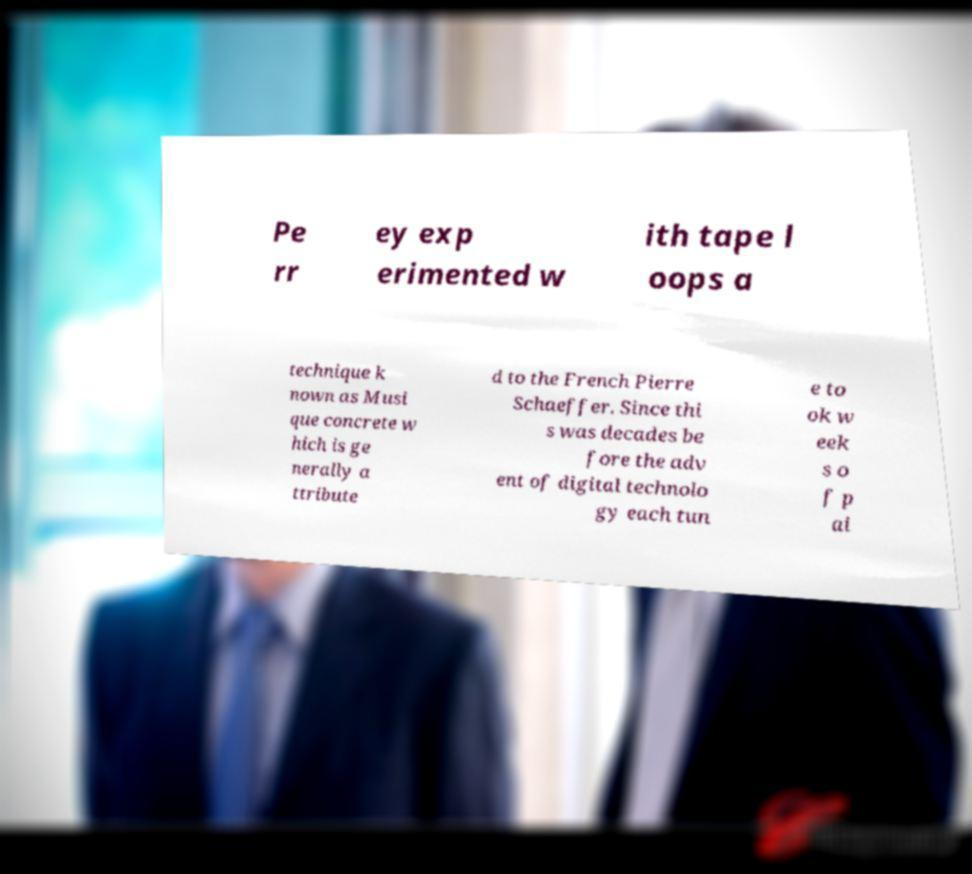What messages or text are displayed in this image? I need them in a readable, typed format. Pe rr ey exp erimented w ith tape l oops a technique k nown as Musi que concrete w hich is ge nerally a ttribute d to the French Pierre Schaeffer. Since thi s was decades be fore the adv ent of digital technolo gy each tun e to ok w eek s o f p ai 